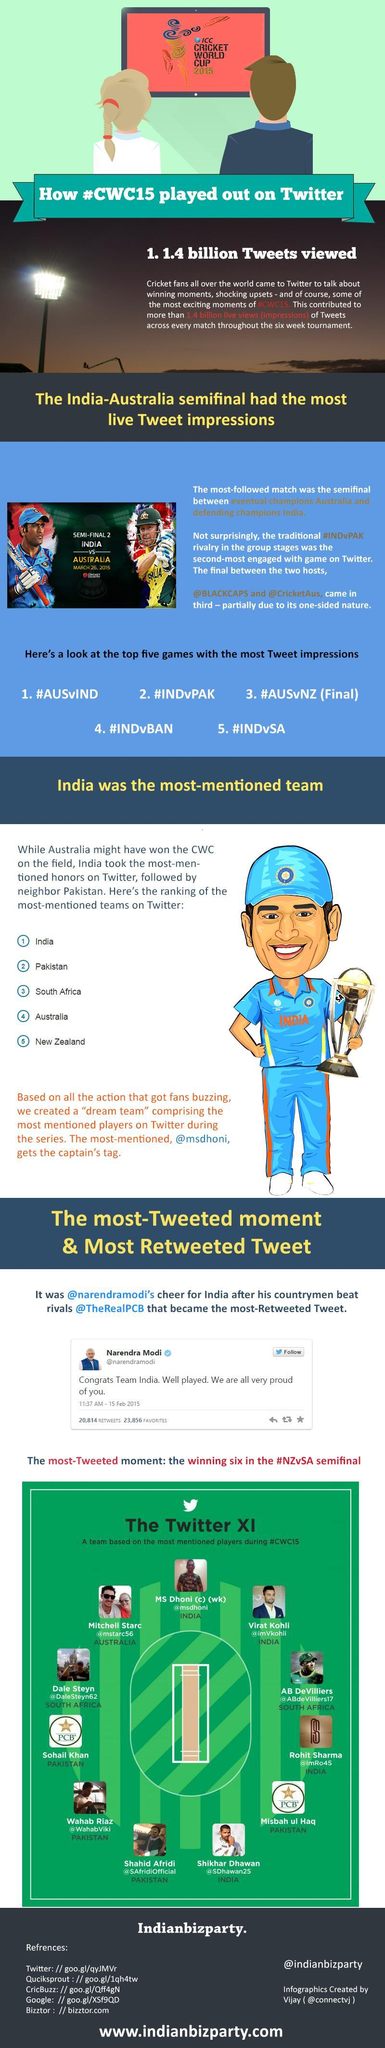Virat Kohli belongs to which country?
Answer the question with a short phrase. India 